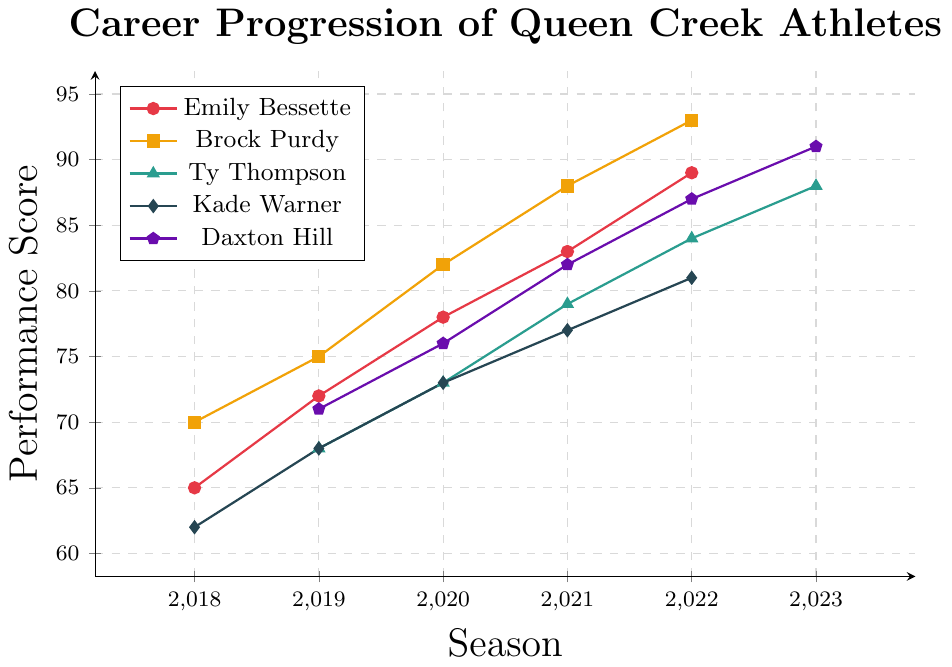Which athlete had the highest performance score in 2022? According to the line chart, Brock Purdy had the highest performance score in 2022. His score surpassed the others at 93.
Answer: Brock Purdy Which athlete showed the most improvement from 2019 to 2022? By comparing the improvement from 2019 to 2022 among the athletes:
Emily Bessette: 89 - 72 = 17
Brock Purdy: 93 - 75 = 18
Kade Warner: 81 - 68 = 13
Ty Thompson: 84 - 68 = 16
Daxton Hill: 87 - 76 = 11
Brock Purdy showed the most improvement.
Answer: Brock Purdy Which athlete had the least improvement over their tracked seasons? By calculating the improvement over tracked seasons for each athlete:
Emily Bessette: 89 - 65 = 24 (2018-2022)
Brock Purdy: 93 - 70 = 23 (2018-2022)
Ty Thompson: 88 - 68 = 20 (2019-2023)
Kade Warner: 81 - 62 = 19 (2018-2022)
Daxton Hill: 91 - 71 = 20 (2019-2023)
Kade Warner had the least improvement.
Answer: Kade Warner What was the average performance score of Emily Bessette over the seasons shown? Adding up the performance scores over the seasons and dividing by the number of seasons: (65 + 72 + 78 + 83 + 89) / 5 = 387 / 5 = 77.4
Answer: 77.4 Which athletes had an equal performance score in any year? By examining the scores for each year across athletes:
Both Ty Thompson and Kade Warner had a score of 73 in 2020.
Answer: Ty Thompson and Kade Warner How did Ty Thompson's performance score change from his first to his last recorded season? Ty Thompson's performance score in 2019 was 68, and in 2023 it was 88. The change is 88 - 68 = 20.
Answer: 20 Did any athlete have a constant rate of improvement, and if so, who? By examining the rate of improvement year over year:
Emily Bessette: +7, +6, +5, +6
Brock Purdy: +5, +7, +6, +5
Kade Warner: +6, +5, +4, +4
Ty Thompson: +5, +6, +5, +4
Daxton Hill: +5, +6, +5, +4
None of the athletes showed a constant rate of improvement.
Answer: None What is the total sum of performance scores for Brock Purdy across all seasons? Adding up Brock Purdy's scores from 2018 to 2022: 70 + 75 + 82 + 88 + 93 = 408
Answer: 408 